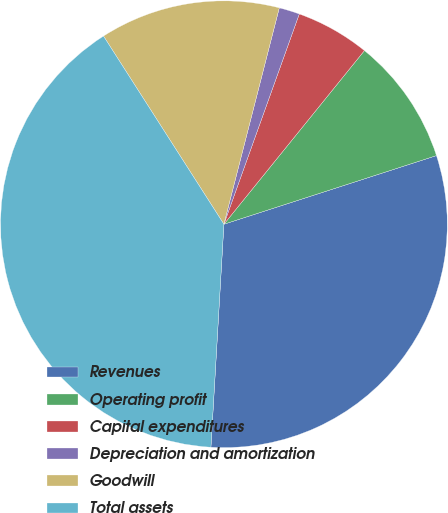Convert chart to OTSL. <chart><loc_0><loc_0><loc_500><loc_500><pie_chart><fcel>Revenues<fcel>Operating profit<fcel>Capital expenditures<fcel>Depreciation and amortization<fcel>Goodwill<fcel>Total assets<nl><fcel>30.9%<fcel>9.2%<fcel>5.35%<fcel>1.49%<fcel>13.05%<fcel>40.02%<nl></chart> 